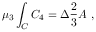<formula> <loc_0><loc_0><loc_500><loc_500>\mu _ { 3 } \int _ { C } C _ { 4 } = \Delta \frac { 2 } { 3 } A \ ,</formula> 